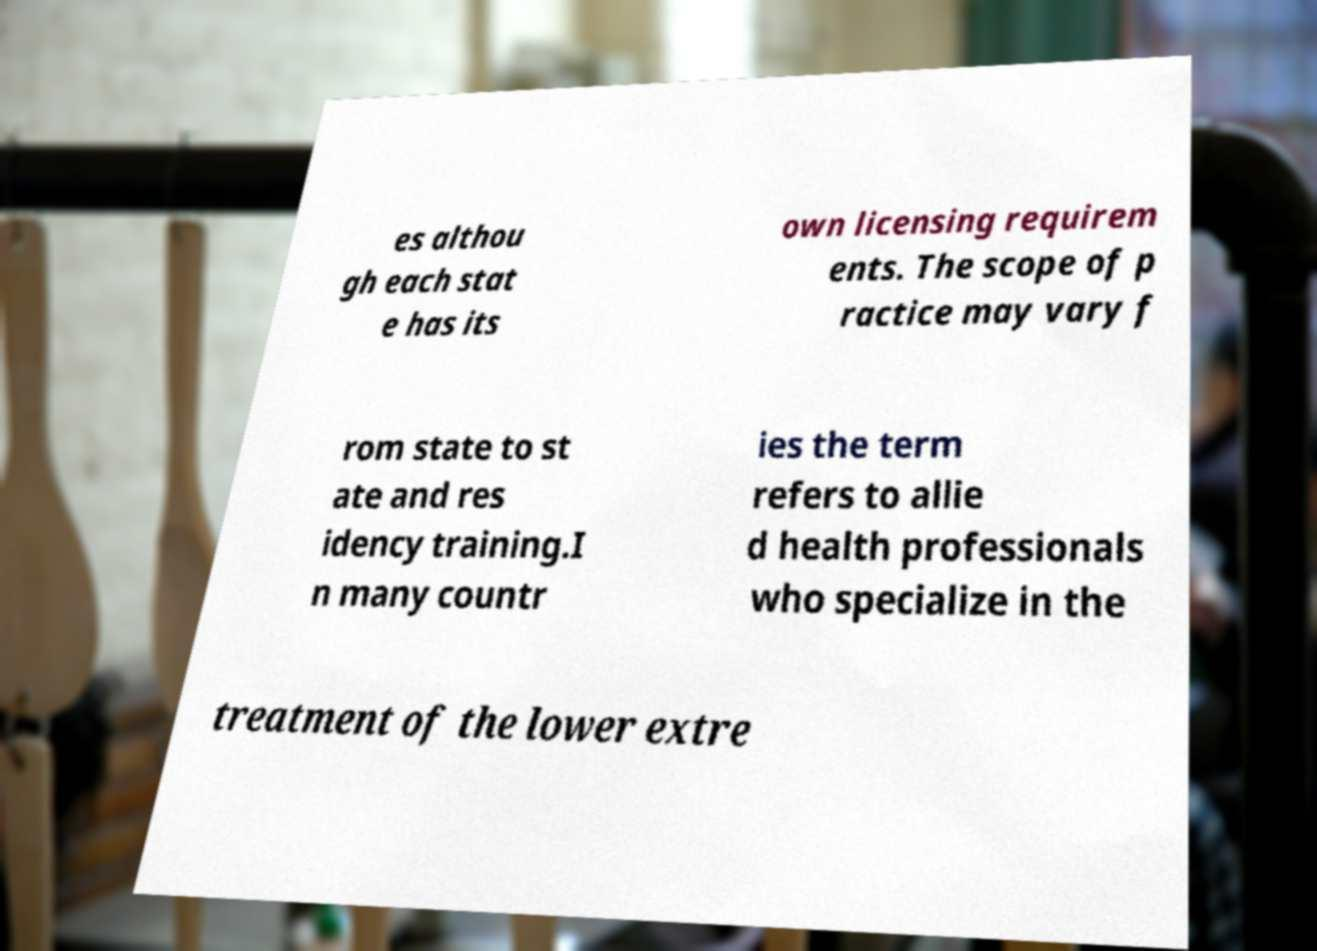For documentation purposes, I need the text within this image transcribed. Could you provide that? es althou gh each stat e has its own licensing requirem ents. The scope of p ractice may vary f rom state to st ate and res idency training.I n many countr ies the term refers to allie d health professionals who specialize in the treatment of the lower extre 